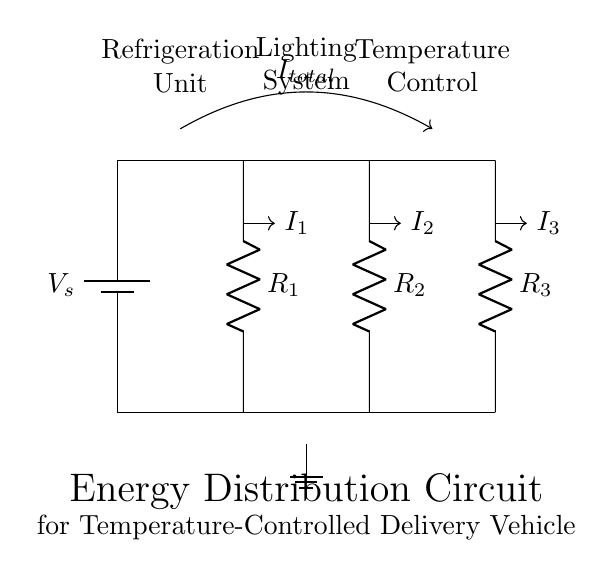What is the total input voltage in this circuit? The total input voltage is represented by \( V_{s} \), which is connected to the top of the resistors.
Answer: \( V_{s} \) What components are used in this circuit? The components in this circuit include three resistors \( R_1, R_2, R_3 \) and a battery \( V_s \).
Answer: Resistors and battery What is the main purpose of this circuit? The main purpose of the circuit is to manage energy distribution for a temperature-controlled delivery vehicle, where different components require energy.
Answer: Energy distribution How many resistors are present in the current divider? There are three resistors present in the current divider portion of the circuit.
Answer: Three What can be said about the relationship between \( I_{total} \), \( I_1 \), \( I_2 \), and \( I_3 \)? The total current \( I_{total} \) is divided into \( I_1, I_2, \) and \( I_3 \) based on the resistance values, following the current divider rule.
Answer: Current division What conclusions can you draw about the current flowing through the resistors? The current flowing through each resistor is inversely proportional to its resistance, meaning that higher resistance draws less current compared to lower resistance.
Answer: Inverse relationship Which component is likely most critical for maintaining temperature? The refrigeration unit is likely the most critical for maintaining the temperature within the vehicle.
Answer: Refrigeration unit 